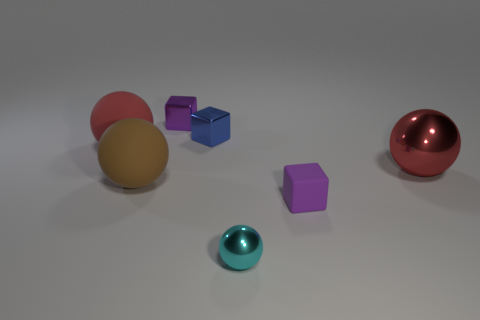Subtract 1 balls. How many balls are left? 3 Subtract all gray balls. Subtract all red blocks. How many balls are left? 4 Add 1 purple blocks. How many objects exist? 8 Subtract all spheres. How many objects are left? 3 Add 1 tiny blue things. How many tiny blue things are left? 2 Add 4 small objects. How many small objects exist? 8 Subtract 0 cyan cylinders. How many objects are left? 7 Subtract all large brown cylinders. Subtract all matte blocks. How many objects are left? 6 